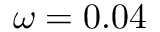Convert formula to latex. <formula><loc_0><loc_0><loc_500><loc_500>\omega = 0 . 0 4</formula> 